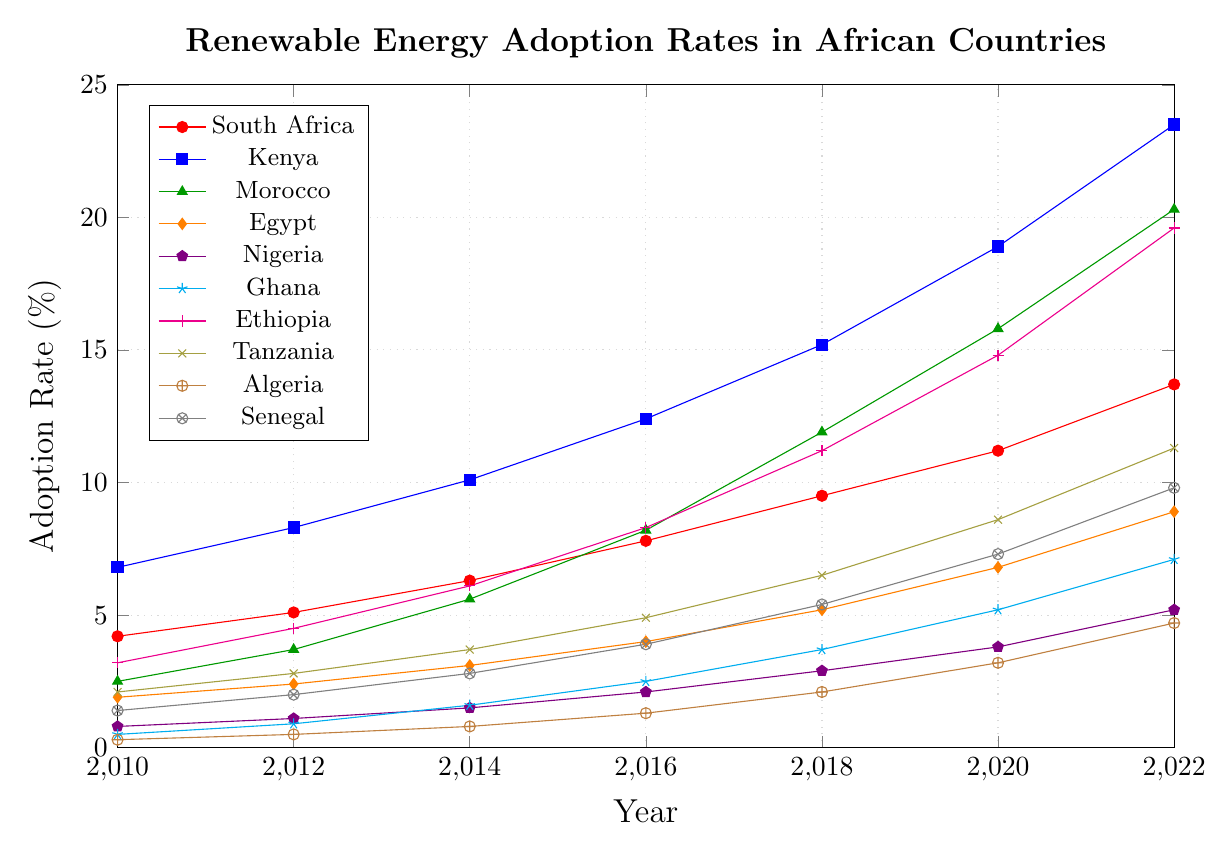Which country has the highest renewable energy adoption rate in 2022? The highest point on the chart for 2022 is associated with Kenya.
Answer: Kenya What is the difference in renewable energy adoption rates between Kenya and Egypt in 2022? The values for Kenya and Egypt in 2022 are 23.5% and 8.9%, respectively. The difference is 23.5% - 8.9% = 14.6%.
Answer: 14.6% Which country showed the highest growth in renewable energy adoption rates from 2010 to 2022? The growth is calculated by subtracting the 2010 value from the 2022 value for each country. The highest growth is seen in Kenya: 23.5% - 6.8% = 16.7%.
Answer: Kenya Has any country reached an adoption rate of at least 20% by 2022? If so, which ones? By 2022, Kenya (23.5%) and Morocco (20.3%) have reached an adoption rate of at least 20%.
Answer: Kenya, Morocco Compare the renewable energy adoption rates of South Africa and Ethiopia in 2016. Which country had a higher rate? The values in 2016 for South Africa and Ethiopia are 7.8% and 8.3%, respectively. Ethiopia had a higher rate.
Answer: Ethiopia What is the average renewable energy adoption rate for South Africa over the years 2010, 2012, and 2014? The adoption rates for South Africa for 2010, 2012, and 2014 are 4.2%, 5.1%, and 6.3%. The average is (4.2 + 5.1 + 6.3) / 3 = 5.2%.
Answer: 5.2% Which countries displayed an adoption rate below 5% in 2020? The countries with an adoption rate below 5% in 2020 are Nigeria (3.8%) and Algeria (3.2%).
Answer: Nigeria, Algeria Did Ghana's renewable energy adoption rate exceed that of Tanzania at any point between 2010 and 2022? A comparison of Ghana and Tanzania over the years shows that Tanzania always had a higher adoption rate than Ghana during this period.
Answer: No What was the trend in renewable energy adoption rates for Egypt from 2010 to 2022? The adoption rate in Egypt shows a steady increase from 1.9% in 2010 to 8.9% in 2022.
Answer: Steady increase Calculate the total adoption rate change for all countries combined from 2010 to 2022. Sum the rates for 2010 and 2022 for all countries and find the difference: (4.2+5.1+6.3+7.8+9.5+11.2+13.7) + (6.8+8.3+10.1+12.4+15.2+18.9+23.5) + (2.5+3.7+5.6+8.2+11.9+15.8+20.3) + (1.9+2.4+3.1+4.0+5.2+6.8+8.9) + (0.8+1.1+1.5+2.1+2.9+3.8+5.2) + (0.5+0.9+1.6+2.5+3.7+5.2+7.1) + (3.2+4.5+6.1+8.3+11.2+14.8+19.6) + (2.1+2.8+3.7+4.9+6.5+8.6+11.3) + (0.3+0.5+0.8+1.3+2.1+3.2+4.7) + (1.4+2.0+2.8+3.9+5.4+7.3+9.8). (Total 2022) - (Total 2010).
Answer: 131.9% 